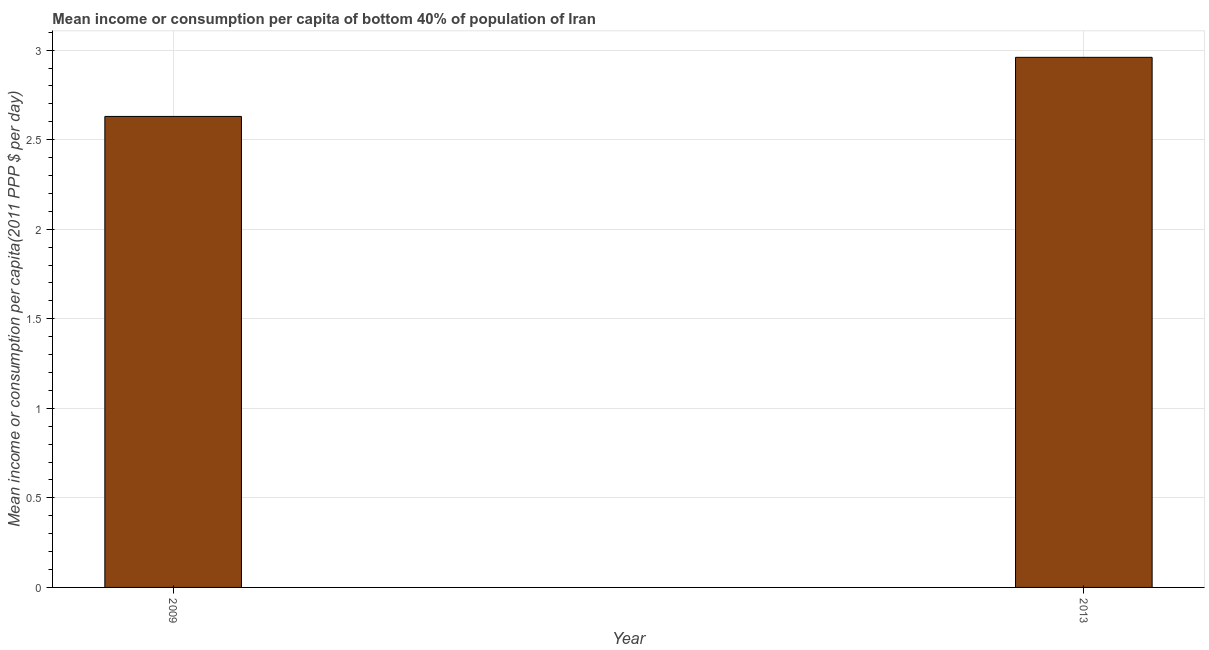Does the graph contain grids?
Keep it short and to the point. Yes. What is the title of the graph?
Your response must be concise. Mean income or consumption per capita of bottom 40% of population of Iran. What is the label or title of the X-axis?
Your answer should be compact. Year. What is the label or title of the Y-axis?
Your answer should be compact. Mean income or consumption per capita(2011 PPP $ per day). What is the mean income or consumption in 2009?
Keep it short and to the point. 2.63. Across all years, what is the maximum mean income or consumption?
Give a very brief answer. 2.96. Across all years, what is the minimum mean income or consumption?
Offer a terse response. 2.63. What is the sum of the mean income or consumption?
Ensure brevity in your answer.  5.59. What is the difference between the mean income or consumption in 2009 and 2013?
Your answer should be compact. -0.33. What is the average mean income or consumption per year?
Make the answer very short. 2.79. What is the median mean income or consumption?
Give a very brief answer. 2.79. In how many years, is the mean income or consumption greater than 1 $?
Your answer should be very brief. 2. Do a majority of the years between 2009 and 2013 (inclusive) have mean income or consumption greater than 2.8 $?
Ensure brevity in your answer.  No. What is the ratio of the mean income or consumption in 2009 to that in 2013?
Make the answer very short. 0.89. In how many years, is the mean income or consumption greater than the average mean income or consumption taken over all years?
Your answer should be very brief. 1. How many bars are there?
Provide a short and direct response. 2. What is the difference between two consecutive major ticks on the Y-axis?
Give a very brief answer. 0.5. What is the Mean income or consumption per capita(2011 PPP $ per day) of 2009?
Give a very brief answer. 2.63. What is the Mean income or consumption per capita(2011 PPP $ per day) of 2013?
Provide a short and direct response. 2.96. What is the difference between the Mean income or consumption per capita(2011 PPP $ per day) in 2009 and 2013?
Make the answer very short. -0.33. What is the ratio of the Mean income or consumption per capita(2011 PPP $ per day) in 2009 to that in 2013?
Your answer should be very brief. 0.89. 